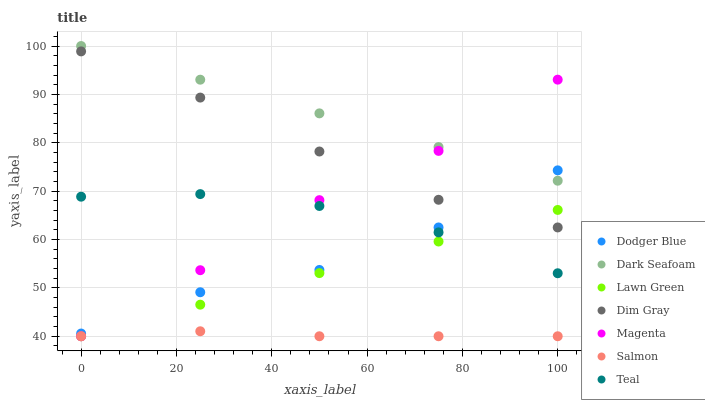Does Salmon have the minimum area under the curve?
Answer yes or no. Yes. Does Dark Seafoam have the maximum area under the curve?
Answer yes or no. Yes. Does Dim Gray have the minimum area under the curve?
Answer yes or no. No. Does Dim Gray have the maximum area under the curve?
Answer yes or no. No. Is Lawn Green the smoothest?
Answer yes or no. Yes. Is Dodger Blue the roughest?
Answer yes or no. Yes. Is Dim Gray the smoothest?
Answer yes or no. No. Is Dim Gray the roughest?
Answer yes or no. No. Does Lawn Green have the lowest value?
Answer yes or no. Yes. Does Dim Gray have the lowest value?
Answer yes or no. No. Does Dark Seafoam have the highest value?
Answer yes or no. Yes. Does Dim Gray have the highest value?
Answer yes or no. No. Is Salmon less than Dark Seafoam?
Answer yes or no. Yes. Is Dark Seafoam greater than Lawn Green?
Answer yes or no. Yes. Does Dodger Blue intersect Teal?
Answer yes or no. Yes. Is Dodger Blue less than Teal?
Answer yes or no. No. Is Dodger Blue greater than Teal?
Answer yes or no. No. Does Salmon intersect Dark Seafoam?
Answer yes or no. No. 